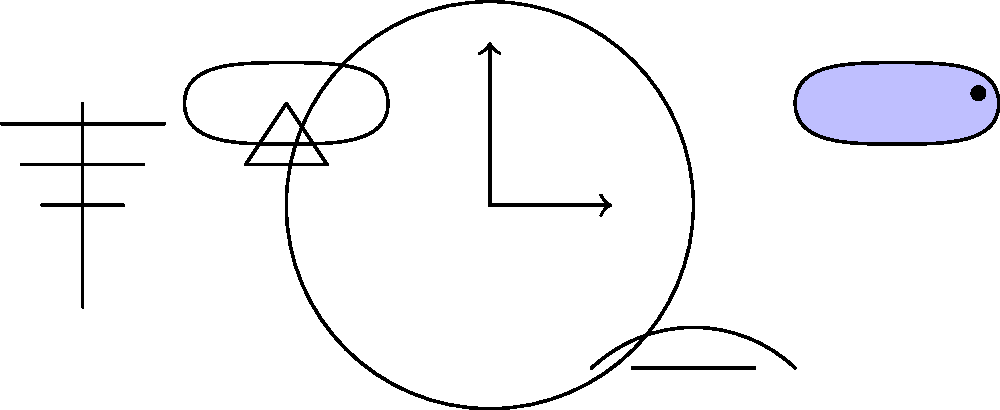In this surrealist composition, which element most prominently challenges our perception of time and reality, and how does it relate to the works of Salvador Dalí? To answer this question, we need to analyze the elements in the composition and their symbolic meanings:

1. Clock: Represents conventional time.
2. Fish: Symbolizes life and movement.
3. Melting watch: A distorted representation of time.
4. Tree: Represents nature and growth.
5. Floating hat: Suggests levitation or the surreal.

The melting watch is the element that most prominently challenges our perception of time and reality. This is because:

1. It distorts a familiar object (watch) associated with measuring time.
2. The fluid, malleable form contradicts the rigid, mechanical nature of timepieces.
3. It suggests that time is subjective and can be manipulated or distorted.

This element directly relates to Salvador Dalí's works, particularly his famous painting "The Persistence of Memory" (1931). In this painting, Dalí featured similar melting watches, which became an iconic symbol of surrealism.

The melting watch in our composition:
1. Echoes Dalí's style and themes.
2. Challenges the viewer's perception of reality.
3. Suggests the fluidity and relativity of time.
4. Represents the intersection of the conscious and subconscious mind, a key concept in surrealism.

By incorporating this element, the composition aligns with surrealist principles of juxtaposing unrelated objects and challenging conventional perceptions, much like Dalí's groundbreaking works in surreal cinema and art.
Answer: Melting watch 